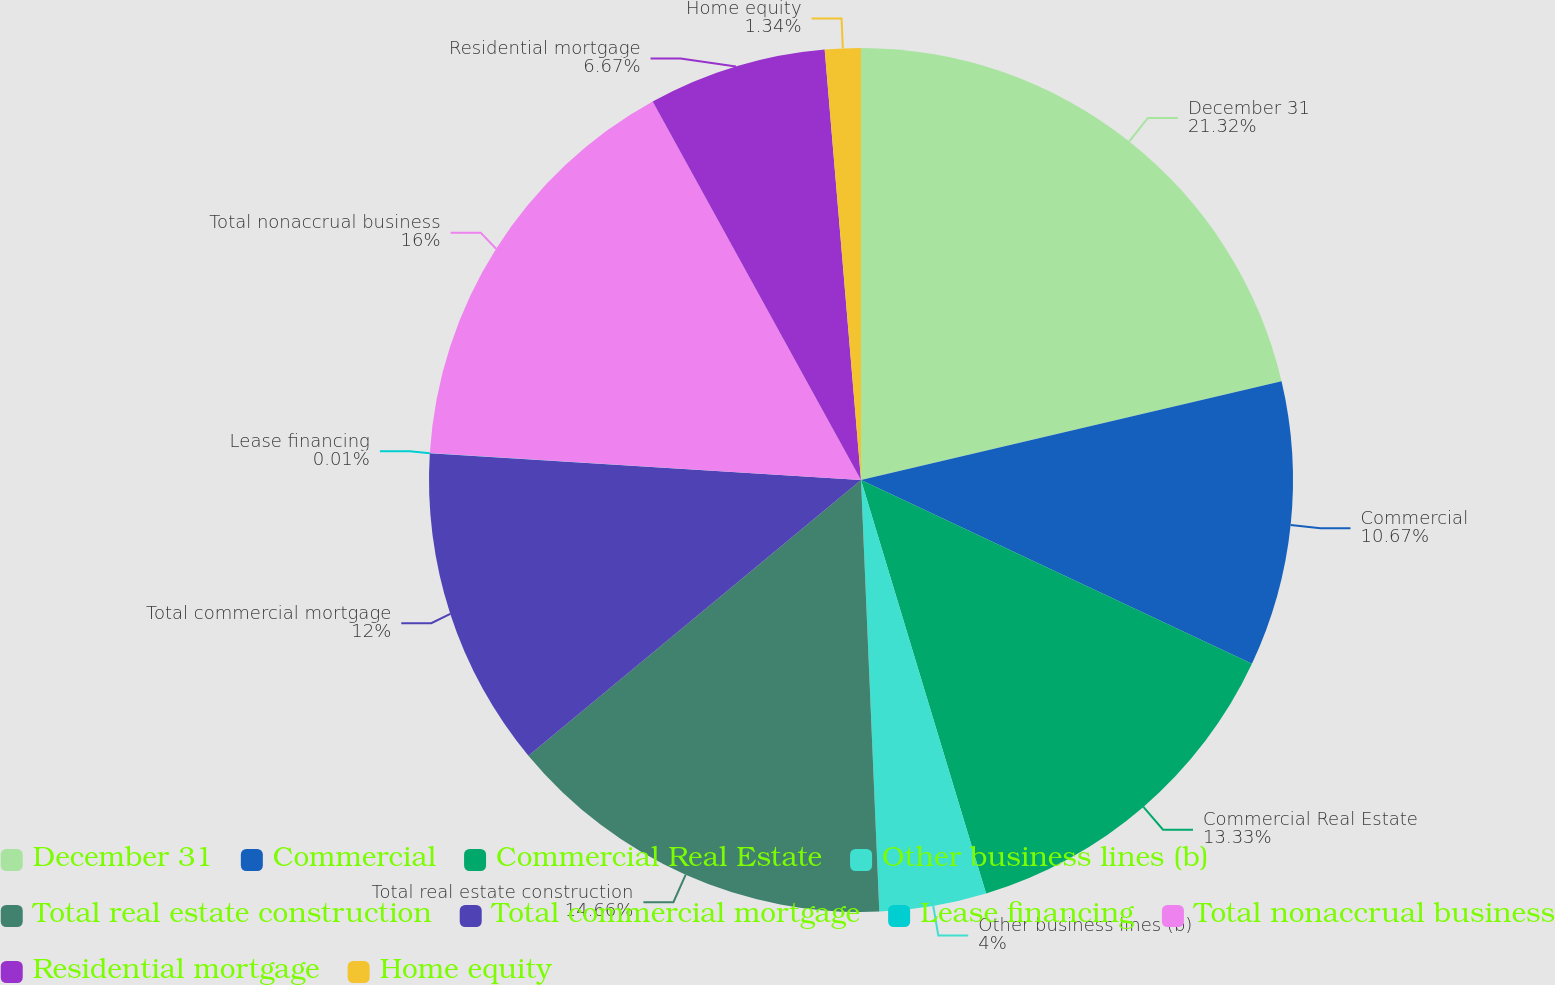Convert chart to OTSL. <chart><loc_0><loc_0><loc_500><loc_500><pie_chart><fcel>December 31<fcel>Commercial<fcel>Commercial Real Estate<fcel>Other business lines (b)<fcel>Total real estate construction<fcel>Total commercial mortgage<fcel>Lease financing<fcel>Total nonaccrual business<fcel>Residential mortgage<fcel>Home equity<nl><fcel>21.33%<fcel>10.67%<fcel>13.33%<fcel>4.0%<fcel>14.66%<fcel>12.0%<fcel>0.01%<fcel>16.0%<fcel>6.67%<fcel>1.34%<nl></chart> 